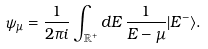<formula> <loc_0><loc_0><loc_500><loc_500>\psi _ { \mu } = \frac { 1 } { 2 \pi i } \int _ { \mathbb { R } ^ { + } } d E \, \frac { 1 } { E - \mu } | E ^ { - } \rangle .</formula> 